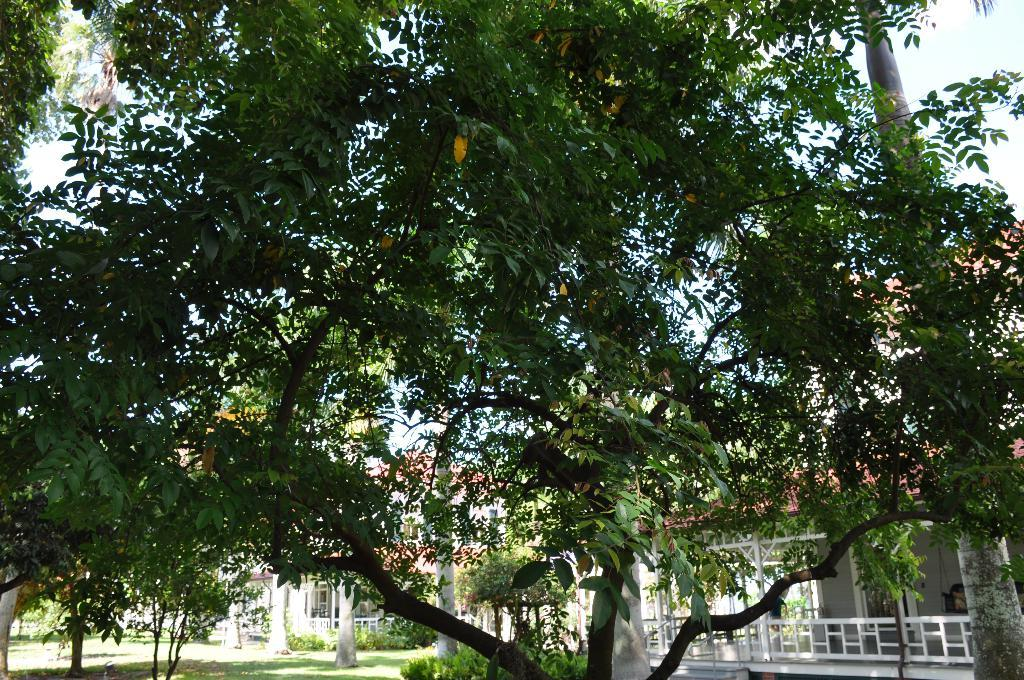What type of vegetation can be seen in the image? There are trees in the image. What type of structures are visible in the image? There are houses in the image. What is at the bottom of the image? There is grass at the bottom of the image. What type of bell can be seen hanging from the trees in the image? There is no bell present in the image; it only features trees, houses, and grass. How many daughters can be seen in the image? There are no people, including daughters, present in the image. 